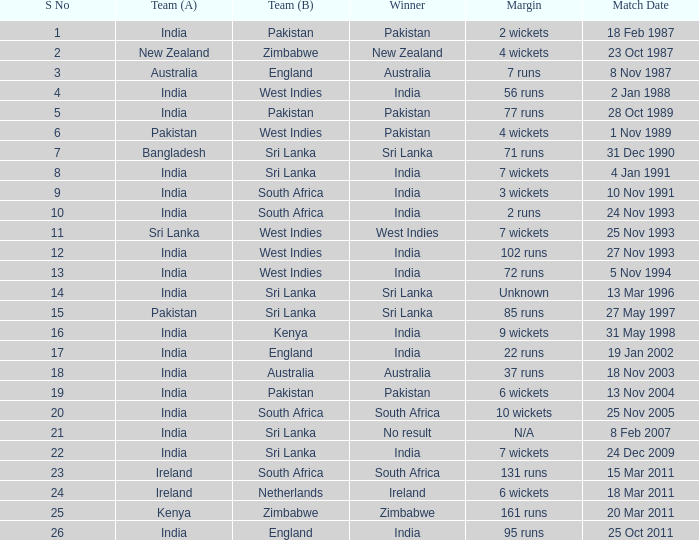What was the spread in the contest on 19 jan 2002? 22 runs. 